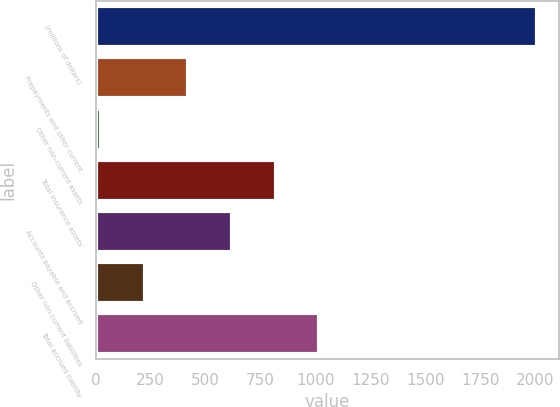Convert chart. <chart><loc_0><loc_0><loc_500><loc_500><bar_chart><fcel>(millions of dollars)<fcel>Prepayments and other current<fcel>Other non-current assets<fcel>Total insurance assets<fcel>Accounts payable and accrued<fcel>Other non-current liabilities<fcel>Total accrued liability<nl><fcel>2010<fcel>421.84<fcel>24.8<fcel>818.88<fcel>620.36<fcel>223.32<fcel>1017.4<nl></chart> 